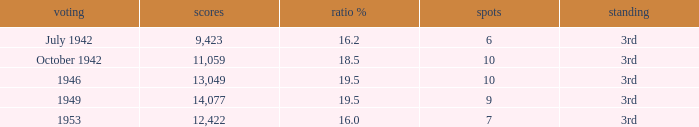Name the most vote % with election of 1946 19.5. 